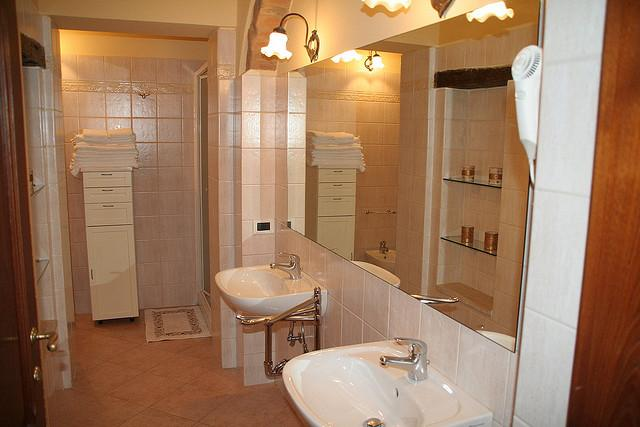What typical bathroom item is integrated into the wall that normally is free standing? sink 